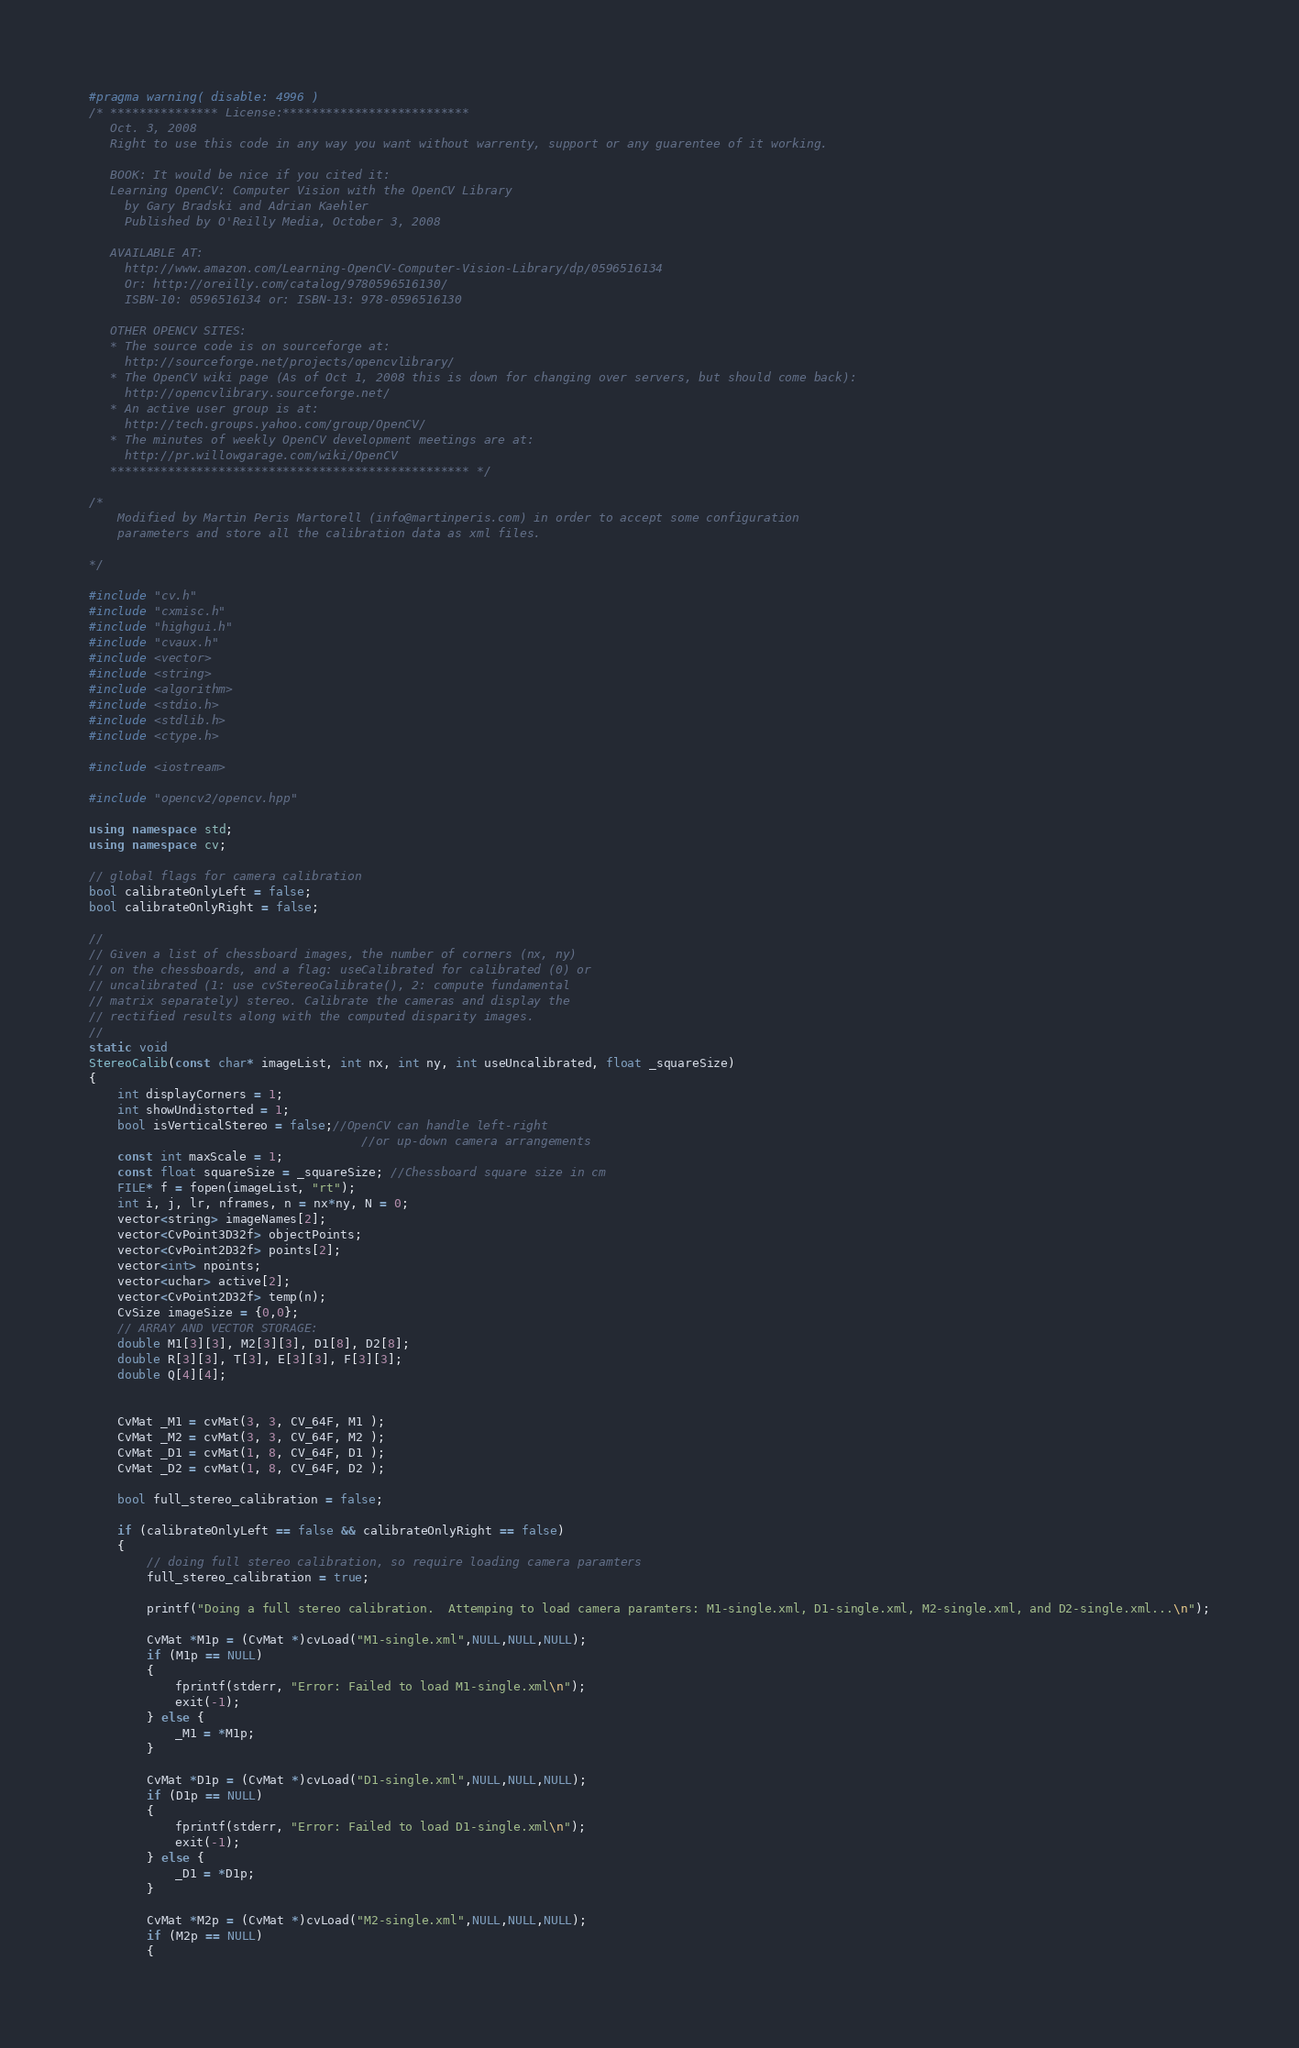<code> <loc_0><loc_0><loc_500><loc_500><_C++_>#pragma warning( disable: 4996 )
/* *************** License:**************************
   Oct. 3, 2008
   Right to use this code in any way you want without warrenty, support or any guarentee of it working.

   BOOK: It would be nice if you cited it:
   Learning OpenCV: Computer Vision with the OpenCV Library
     by Gary Bradski and Adrian Kaehler
     Published by O'Reilly Media, October 3, 2008
 
   AVAILABLE AT: 
     http://www.amazon.com/Learning-OpenCV-Computer-Vision-Library/dp/0596516134
     Or: http://oreilly.com/catalog/9780596516130/
     ISBN-10: 0596516134 or: ISBN-13: 978-0596516130    

   OTHER OPENCV SITES:
   * The source code is on sourceforge at:
     http://sourceforge.net/projects/opencvlibrary/
   * The OpenCV wiki page (As of Oct 1, 2008 this is down for changing over servers, but should come back):
     http://opencvlibrary.sourceforge.net/
   * An active user group is at:
     http://tech.groups.yahoo.com/group/OpenCV/
   * The minutes of weekly OpenCV development meetings are at:
     http://pr.willowgarage.com/wiki/OpenCV
   ************************************************** */

/*
	Modified by Martin Peris Martorell (info@martinperis.com) in order to accept some configuration
	parameters and store all the calibration data as xml files.

*/

#include "cv.h"
#include "cxmisc.h"
#include "highgui.h"
#include "cvaux.h"
#include <vector>
#include <string>
#include <algorithm>
#include <stdio.h>
#include <stdlib.h>
#include <ctype.h>

#include <iostream>

#include "opencv2/opencv.hpp"

using namespace std;
using namespace cv;

// global flags for camera calibration
bool calibrateOnlyLeft = false;
bool calibrateOnlyRight = false;

//
// Given a list of chessboard images, the number of corners (nx, ny)
// on the chessboards, and a flag: useCalibrated for calibrated (0) or
// uncalibrated (1: use cvStereoCalibrate(), 2: compute fundamental
// matrix separately) stereo. Calibrate the cameras and display the
// rectified results along with the computed disparity images.
//
static void
StereoCalib(const char* imageList, int nx, int ny, int useUncalibrated, float _squareSize)
{
    int displayCorners = 1;
    int showUndistorted = 1;
    bool isVerticalStereo = false;//OpenCV can handle left-right
                                      //or up-down camera arrangements
    const int maxScale = 1;
    const float squareSize = _squareSize; //Chessboard square size in cm
    FILE* f = fopen(imageList, "rt");
    int i, j, lr, nframes, n = nx*ny, N = 0;
    vector<string> imageNames[2];
    vector<CvPoint3D32f> objectPoints;
    vector<CvPoint2D32f> points[2];
    vector<int> npoints;
    vector<uchar> active[2];
    vector<CvPoint2D32f> temp(n);
    CvSize imageSize = {0,0};
    // ARRAY AND VECTOR STORAGE:
    double M1[3][3], M2[3][3], D1[8], D2[8];
    double R[3][3], T[3], E[3][3], F[3][3];
    double Q[4][4];
    
    
    CvMat _M1 = cvMat(3, 3, CV_64F, M1 );
    CvMat _M2 = cvMat(3, 3, CV_64F, M2 );
    CvMat _D1 = cvMat(1, 8, CV_64F, D1 );
    CvMat _D2 = cvMat(1, 8, CV_64F, D2 );

    bool full_stereo_calibration = false;
    
    if (calibrateOnlyLeft == false && calibrateOnlyRight == false)
    {
        // doing full stereo calibration, so require loading camera paramters
        full_stereo_calibration = true;
        
        printf("Doing a full stereo calibration.  Attemping to load camera paramters: M1-single.xml, D1-single.xml, M2-single.xml, and D2-single.xml...\n");
        
        CvMat *M1p = (CvMat *)cvLoad("M1-single.xml",NULL,NULL,NULL);
        if (M1p == NULL)
        {
            fprintf(stderr, "Error: Failed to load M1-single.xml\n");
            exit(-1);
        } else {
            _M1 = *M1p;
        }
        
        CvMat *D1p = (CvMat *)cvLoad("D1-single.xml",NULL,NULL,NULL);
        if (D1p == NULL)
        {
            fprintf(stderr, "Error: Failed to load D1-single.xml\n");
            exit(-1);
        } else {
            _D1 = *D1p;
        }
        
        CvMat *M2p = (CvMat *)cvLoad("M2-single.xml",NULL,NULL,NULL);
        if (M2p == NULL)
        {</code> 